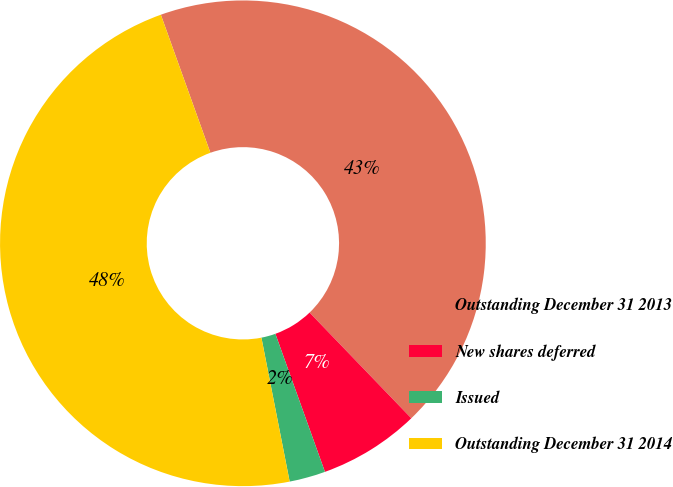<chart> <loc_0><loc_0><loc_500><loc_500><pie_chart><fcel>Outstanding December 31 2013�<fcel>New shares deferred � � � � �<fcel>Issued � � � � � � � � � � � �<fcel>Outstanding December 31 2014 �<nl><fcel>43.29%<fcel>6.71%<fcel>2.4%<fcel>47.6%<nl></chart> 